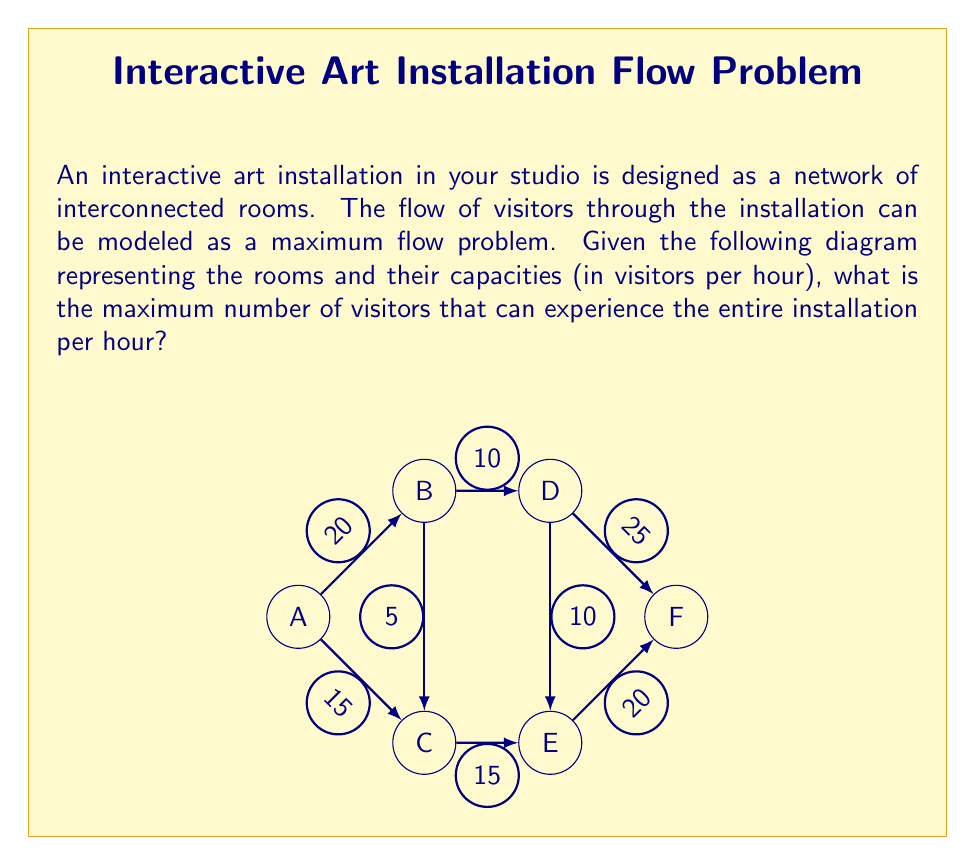Can you solve this math problem? To solve this maximum flow problem, we'll use the Ford-Fulkerson algorithm:

1) Initialize flow to 0 for all edges.

2) Find an augmenting path from A to F:
   Path 1: A -> B -> D -> F (min capacity = 10)
   Update flow: A->B: 10, B->D: 10, D->F: 10
   Residual capacities: A->B: 10, B->D: 0, D->F: 15

3) Find another augmenting path:
   Path 2: A -> C -> E -> F (min capacity = 15)
   Update flow: A->C: 15, C->E: 15, E->F: 15
   Residual capacities: A->C: 0, C->E: 0, E->F: 5

4) Find another augmenting path:
   Path 3: A -> B -> C -> E -> F (min capacity = 5)
   Update flow: A->B: 5, B->C: 5, C->E: 5, E->F: 5
   Residual capacities: A->B: 5, B->C: 0, C->E: 0, E->F: 0

5) No more augmenting paths exist.

The maximum flow is the sum of all flows out of A:
$$\text{Max Flow} = 10 + 15 + 5 = 30$$

Therefore, the maximum number of visitors that can experience the entire installation per hour is 30.
Answer: 30 visitors per hour 